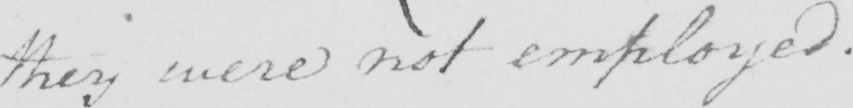Can you read and transcribe this handwriting? they were not employed . 